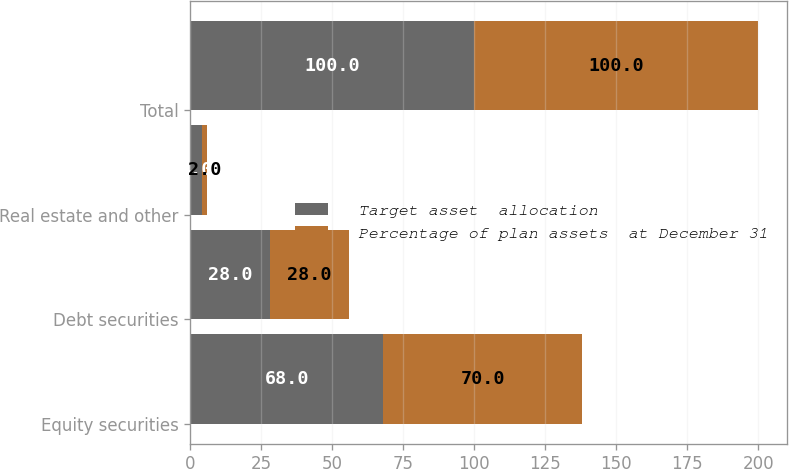Convert chart. <chart><loc_0><loc_0><loc_500><loc_500><stacked_bar_chart><ecel><fcel>Equity securities<fcel>Debt securities<fcel>Real estate and other<fcel>Total<nl><fcel>Target asset  allocation<fcel>68<fcel>28<fcel>4<fcel>100<nl><fcel>Percentage of plan assets  at December 31<fcel>70<fcel>28<fcel>2<fcel>100<nl></chart> 